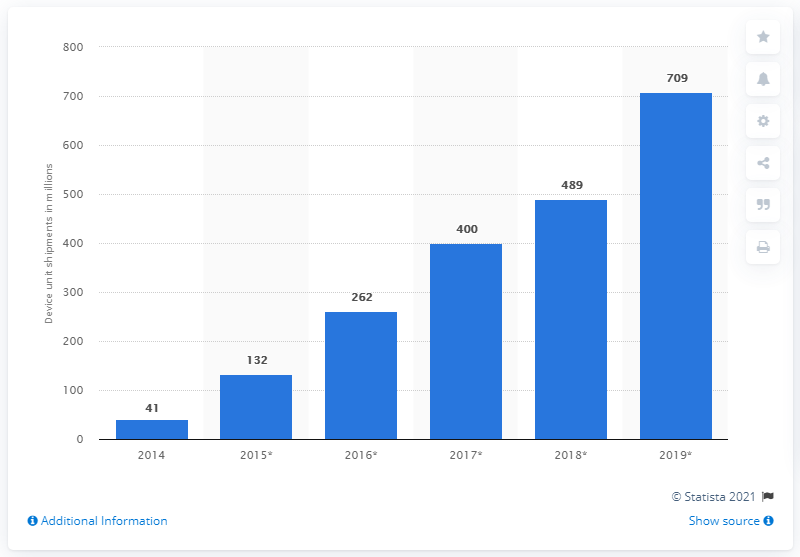Outline some significant characteristics in this image. According to the forecast, the number of connected home security device shipments is expected to reach a global total of 489 from 2014 to 2019. 